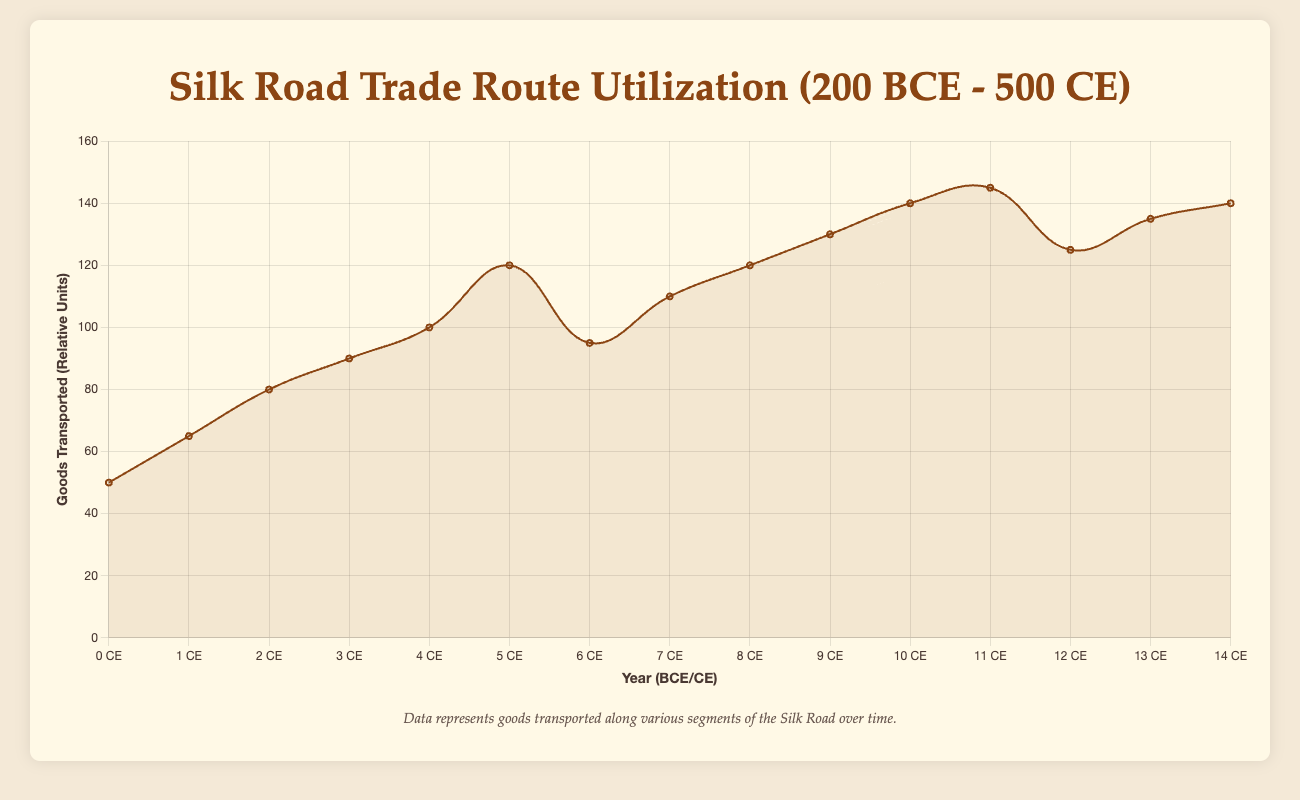What is the overall trend of goods transported from 200 BCE to 500 CE? The overall trend shows an increase in the amount of goods transported over time, with a few fluctuations, especially peaking around 350 CE before slightly dropping and then rising again. The plot starts at 50 in 200 BCE and ends at 140 in 500 CE.
Answer: Increasing trend In which year was the highest volume of goods transported and what was the value? The highest volume of goods transported was in 350 CE, reaching 145 units. This peak is visually higher than other years in the timeline.
Answer: 350 CE, 145 units Compare the trade intensity between 0 CE and 50 CE. Which year had more goods transported and by how much? In 0 CE, the goods transported were 100 units, and in 50 CE, it was 120 units. By comparing these two values, 50 CE had 20 more units compared to 0 CE.
Answer: 50 CE, 20 units Which route segment shows a notable increase in goods transported corresponding with the rise of the Sassanian Empire? The route segment from Samarkand to Ctesiphon sees a notable increase in goods transported corresponding with the rise of the Sassanian Empire around the year 250 CE. This segment had 130 units transported during this period.
Answer: Samarkand to Ctesiphon What is the average volume of goods transported every 100 years from 200 BCE to 500 CE? To find the average, sum the goods transported every 100 years: (50 + 80 + 100 + 95 + 120 + 140 + 125 + 140) = 850. There are 8 points, so the average is 850/8 = 106.25 units
Answer: 106.25 units Identify the period with the steepest increase in goods transported and quantify the increase. The steepest increase in goods transported occurred between 0 CE and 50 CE. The goods transported increased from 100 to 120 units, showing an increase of 20 units over these 50 years.
Answer: 0 CE to 50 CE, 20 units Describe the visual appearance of the trend line between 400 CE and 500 CE. The trend line between 400 CE and 500 CE shows an upward trajectory, moving from a low point at 400 CE (125 units) to a high point at 500 CE (140 units). The line visually represents this rise as a steady incline.
Answer: Steady incline What is the total goods transported from Chang'an to Dunhuang across all recorded years? Summing the GoodsTransported values for Chang'an to Dunhuang across 200 BCE, 100 CE, and 400 CE: 50 + 95 + 125 = 270 units.
Answer: 270 units When did the goods transported from Samarkand to Ctesiphon peak and what were the values before and after? The goods transported from Samarkand to Ctesiphon peaked at 130 units in 250 CE. The value before it in 200 CE was 120 units, and afterward in 300 CE, it increased to 140 units.
Answer: Peaked in 250 CE, 120 units before, 140 units after Which two periods show a slight decline in the trade intensity before rising again and what were the values at each step? The periods are 50 CE to 100 CE and 350 CE to 400 CE. From 50 CE (120 units) to 100 CE (95 units), there's a decline of 25 units. From 350 CE (145 units) to 400 CE (125 units), there's a decline of 20 units.
Answer: 50 CE to 100 CE (120 --> 95), 350 CE to 400 CE (145 --> 125) 